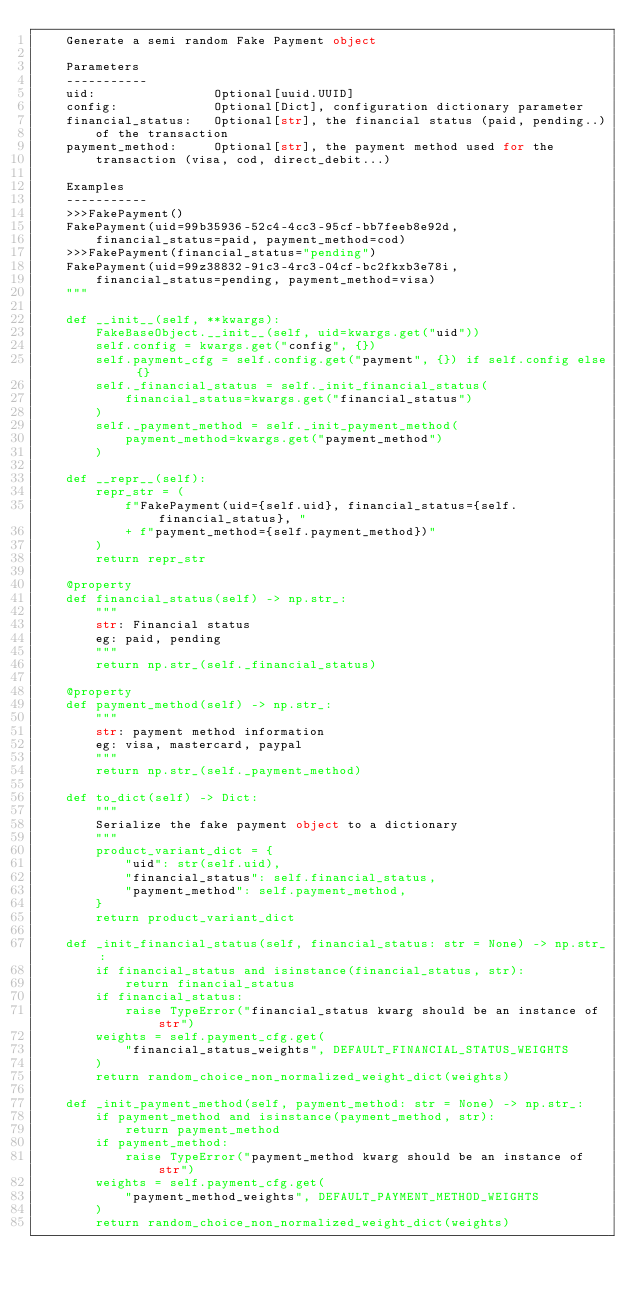<code> <loc_0><loc_0><loc_500><loc_500><_Python_>    Generate a semi random Fake Payment object

    Parameters
    -----------
    uid:                Optional[uuid.UUID]
    config:             Optional[Dict], configuration dictionary parameter
    financial_status:   Optional[str], the financial status (paid, pending..)
        of the transaction
    payment_method:     Optional[str], the payment method used for the
        transaction (visa, cod, direct_debit...)

    Examples
    -----------
    >>>FakePayment()
    FakePayment(uid=99b35936-52c4-4cc3-95cf-bb7feeb8e92d,
        financial_status=paid, payment_method=cod)
    >>>FakePayment(financial_status="pending")
    FakePayment(uid=99z38832-91c3-4rc3-04cf-bc2fkxb3e78i,
        financial_status=pending, payment_method=visa)
    """

    def __init__(self, **kwargs):
        FakeBaseObject.__init__(self, uid=kwargs.get("uid"))
        self.config = kwargs.get("config", {})
        self.payment_cfg = self.config.get("payment", {}) if self.config else {}
        self._financial_status = self._init_financial_status(
            financial_status=kwargs.get("financial_status")
        )
        self._payment_method = self._init_payment_method(
            payment_method=kwargs.get("payment_method")
        )

    def __repr__(self):
        repr_str = (
            f"FakePayment(uid={self.uid}, financial_status={self.financial_status}, "
            + f"payment_method={self.payment_method})"
        )
        return repr_str

    @property
    def financial_status(self) -> np.str_:
        """
        str: Financial status
        eg: paid, pending
        """
        return np.str_(self._financial_status)

    @property
    def payment_method(self) -> np.str_:
        """
        str: payment method information
        eg: visa, mastercard, paypal
        """
        return np.str_(self._payment_method)

    def to_dict(self) -> Dict:
        """
        Serialize the fake payment object to a dictionary
        """
        product_variant_dict = {
            "uid": str(self.uid),
            "financial_status": self.financial_status,
            "payment_method": self.payment_method,
        }
        return product_variant_dict

    def _init_financial_status(self, financial_status: str = None) -> np.str_:
        if financial_status and isinstance(financial_status, str):
            return financial_status
        if financial_status:
            raise TypeError("financial_status kwarg should be an instance of str")
        weights = self.payment_cfg.get(
            "financial_status_weights", DEFAULT_FINANCIAL_STATUS_WEIGHTS
        )
        return random_choice_non_normalized_weight_dict(weights)

    def _init_payment_method(self, payment_method: str = None) -> np.str_:
        if payment_method and isinstance(payment_method, str):
            return payment_method
        if payment_method:
            raise TypeError("payment_method kwarg should be an instance of str")
        weights = self.payment_cfg.get(
            "payment_method_weights", DEFAULT_PAYMENT_METHOD_WEIGHTS
        )
        return random_choice_non_normalized_weight_dict(weights)
</code> 